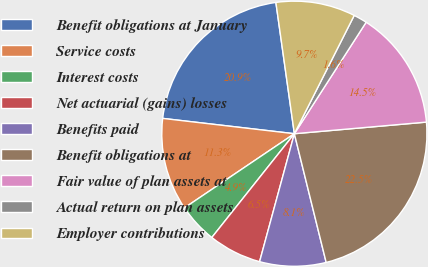Convert chart to OTSL. <chart><loc_0><loc_0><loc_500><loc_500><pie_chart><fcel>Benefit obligations at January<fcel>Service costs<fcel>Interest costs<fcel>Net actuarial (gains) losses<fcel>Benefits paid<fcel>Benefit obligations at<fcel>Fair value of plan assets at<fcel>Actual return on plan assets<fcel>Employer contributions<nl><fcel>20.93%<fcel>11.29%<fcel>4.86%<fcel>6.47%<fcel>8.08%<fcel>22.54%<fcel>14.5%<fcel>1.65%<fcel>9.68%<nl></chart> 